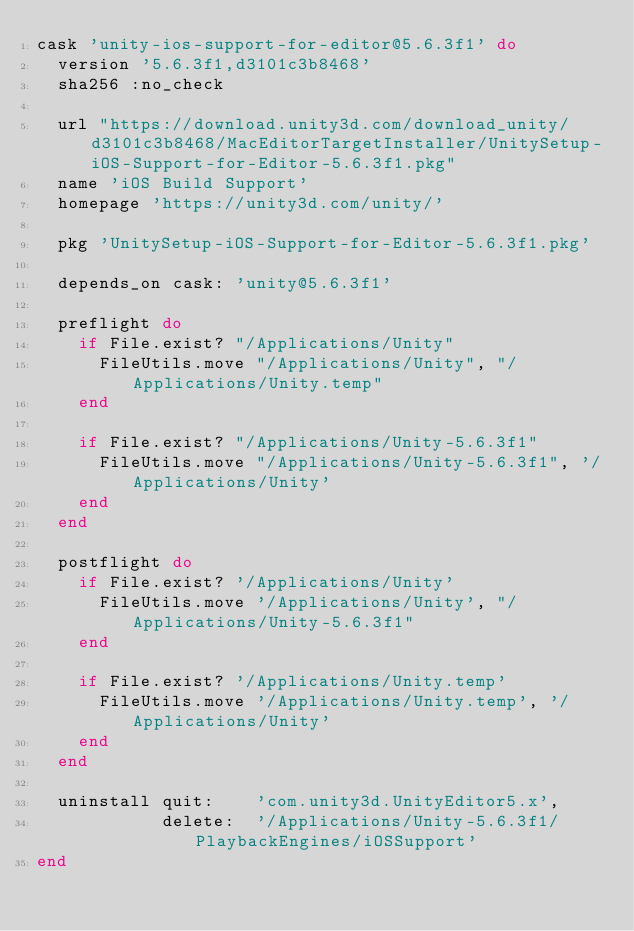Convert code to text. <code><loc_0><loc_0><loc_500><loc_500><_Ruby_>cask 'unity-ios-support-for-editor@5.6.3f1' do
  version '5.6.3f1,d3101c3b8468'
  sha256 :no_check

  url "https://download.unity3d.com/download_unity/d3101c3b8468/MacEditorTargetInstaller/UnitySetup-iOS-Support-for-Editor-5.6.3f1.pkg"
  name 'iOS Build Support'
  homepage 'https://unity3d.com/unity/'

  pkg 'UnitySetup-iOS-Support-for-Editor-5.6.3f1.pkg'

  depends_on cask: 'unity@5.6.3f1'

  preflight do
    if File.exist? "/Applications/Unity"
      FileUtils.move "/Applications/Unity", "/Applications/Unity.temp"
    end

    if File.exist? "/Applications/Unity-5.6.3f1"
      FileUtils.move "/Applications/Unity-5.6.3f1", '/Applications/Unity'
    end
  end

  postflight do
    if File.exist? '/Applications/Unity'
      FileUtils.move '/Applications/Unity', "/Applications/Unity-5.6.3f1"
    end

    if File.exist? '/Applications/Unity.temp'
      FileUtils.move '/Applications/Unity.temp', '/Applications/Unity'
    end
  end

  uninstall quit:    'com.unity3d.UnityEditor5.x',
            delete:  '/Applications/Unity-5.6.3f1/PlaybackEngines/iOSSupport'
end
</code> 